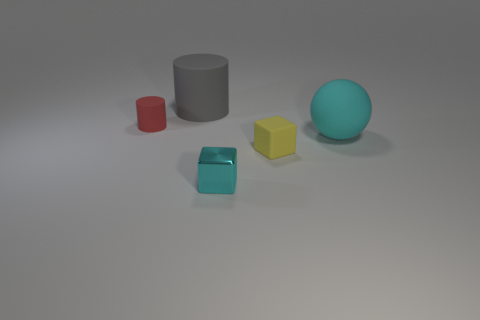Is there any other thing that has the same material as the tiny cyan object?
Your response must be concise. No. There is a object that is behind the yellow matte object and on the right side of the big cylinder; what size is it?
Ensure brevity in your answer.  Large. What material is the other small object that is the same shape as the tiny metallic thing?
Your answer should be compact. Rubber. There is a cylinder on the left side of the big rubber object that is to the left of the large cyan rubber sphere; what is its material?
Make the answer very short. Rubber. Is the shape of the shiny thing the same as the large rubber object that is right of the big cylinder?
Offer a terse response. No. What number of shiny objects are tiny red cylinders or gray things?
Your response must be concise. 0. The big object that is to the right of the tiny matte thing that is in front of the cyan object on the right side of the tiny cyan block is what color?
Offer a very short reply. Cyan. How many other things are there of the same material as the big cylinder?
Give a very brief answer. 3. Do the matte thing to the left of the gray matte object and the cyan shiny thing have the same shape?
Offer a very short reply. No. How many big things are cyan matte objects or cyan matte cylinders?
Provide a short and direct response. 1. 